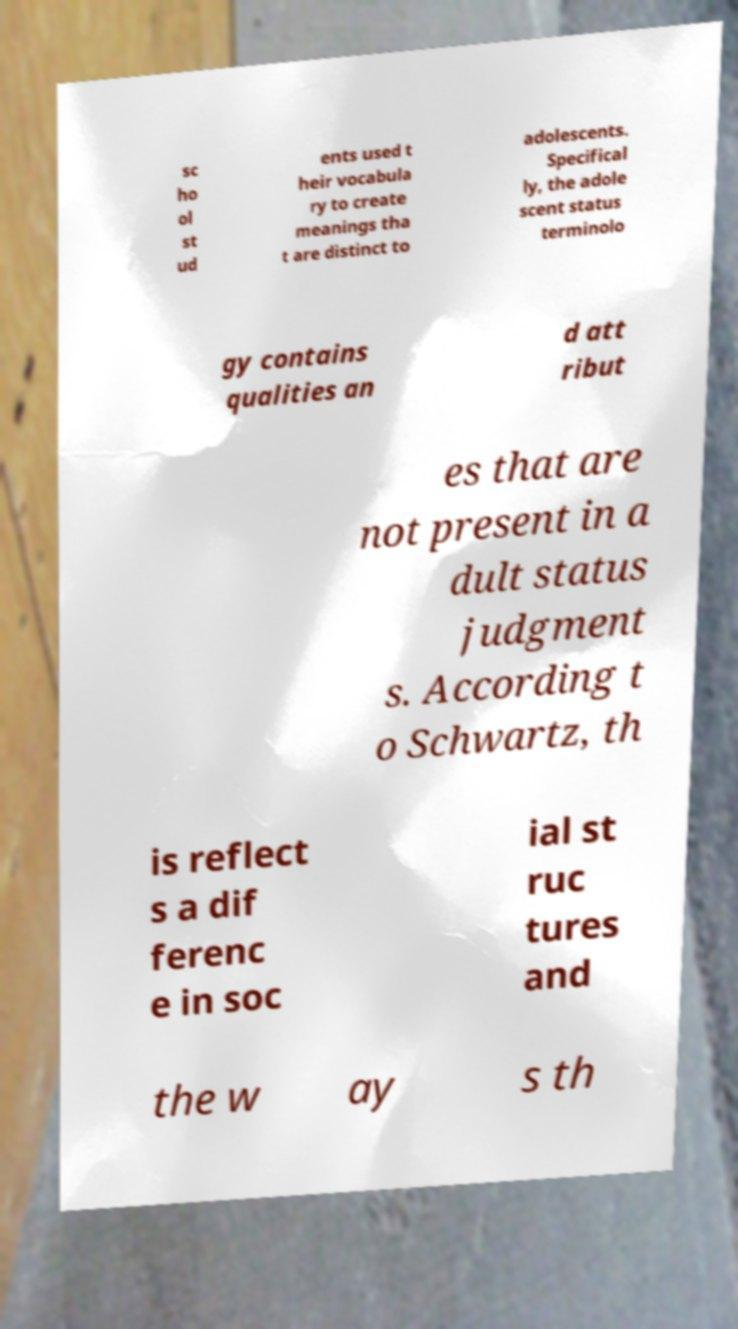I need the written content from this picture converted into text. Can you do that? sc ho ol st ud ents used t heir vocabula ry to create meanings tha t are distinct to adolescents. Specifical ly, the adole scent status terminolo gy contains qualities an d att ribut es that are not present in a dult status judgment s. According t o Schwartz, th is reflect s a dif ferenc e in soc ial st ruc tures and the w ay s th 